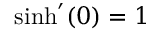<formula> <loc_0><loc_0><loc_500><loc_500>\sinh ^ { \prime } ( 0 ) = 1</formula> 